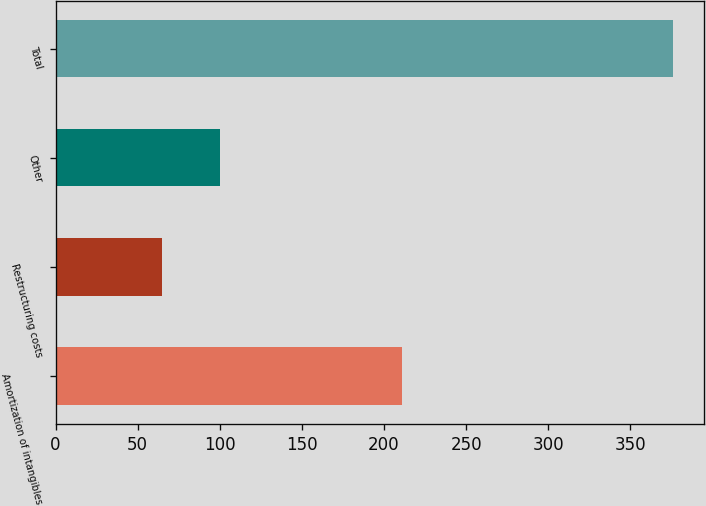Convert chart to OTSL. <chart><loc_0><loc_0><loc_500><loc_500><bar_chart><fcel>Amortization of intangibles<fcel>Restructuring costs<fcel>Other<fcel>Total<nl><fcel>211<fcel>65<fcel>100<fcel>376<nl></chart> 